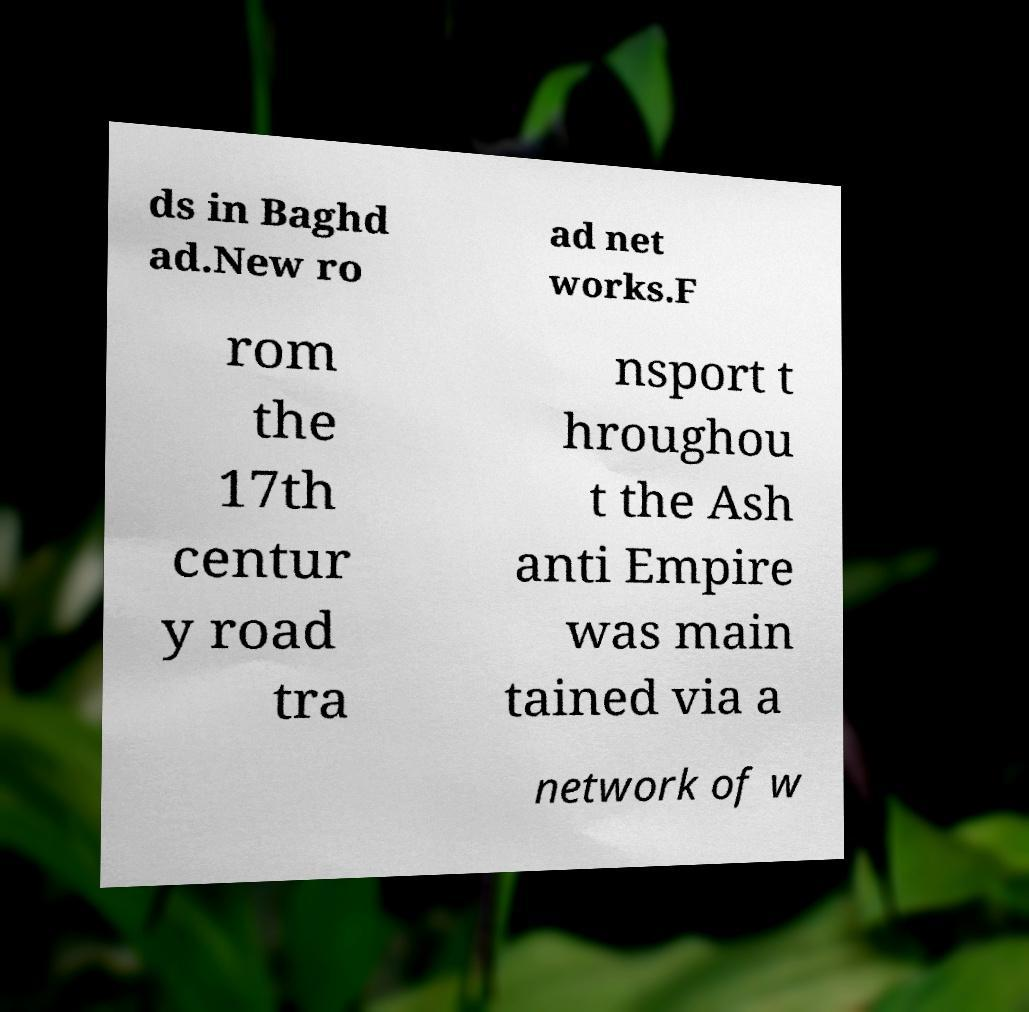For documentation purposes, I need the text within this image transcribed. Could you provide that? ds in Baghd ad.New ro ad net works.F rom the 17th centur y road tra nsport t hroughou t the Ash anti Empire was main tained via a network of w 